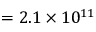<formula> <loc_0><loc_0><loc_500><loc_500>= 2 . 1 \times 1 0 ^ { 1 1 }</formula> 